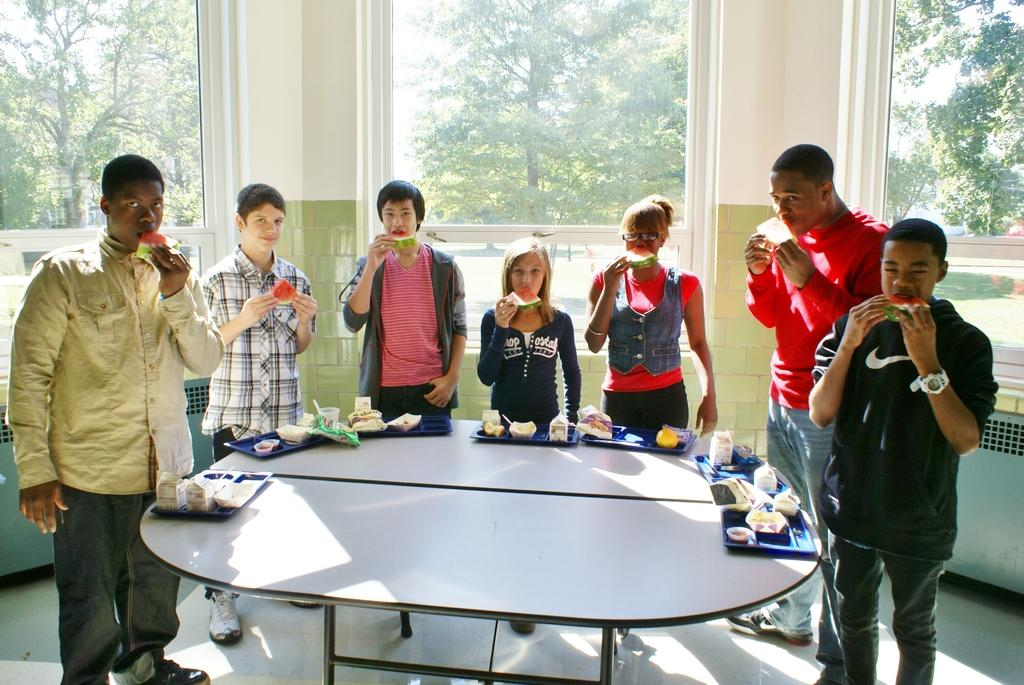What type of vegetation can be seen in the image? There are trees in the image. What architectural feature is present in the image? There is a window in the image. Who or what is visible in the image? There are people standing in the image. What piece of furniture is in the image? There is a table in the image. What items are on the table? There are plates, glasses, and food items on the table. Can you tell me how many tests are being conducted in the image? There is no mention of any tests being conducted in the image. Are there any parents visible in the image? There is no mention of any parents in the image. 